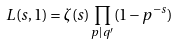<formula> <loc_0><loc_0><loc_500><loc_500>L ( s , 1 ) = \zeta ( s ) \prod _ { p | q ^ { \prime } } ( 1 - p ^ { - s } )</formula> 